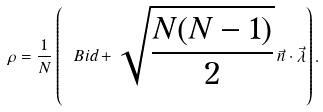Convert formula to latex. <formula><loc_0><loc_0><loc_500><loc_500>\rho = \frac { 1 } { N } \left ( \ B i d + \sqrt { \frac { N ( N - 1 ) } { 2 } } \, \vec { n } \cdot \vec { \lambda } \right ) .</formula> 